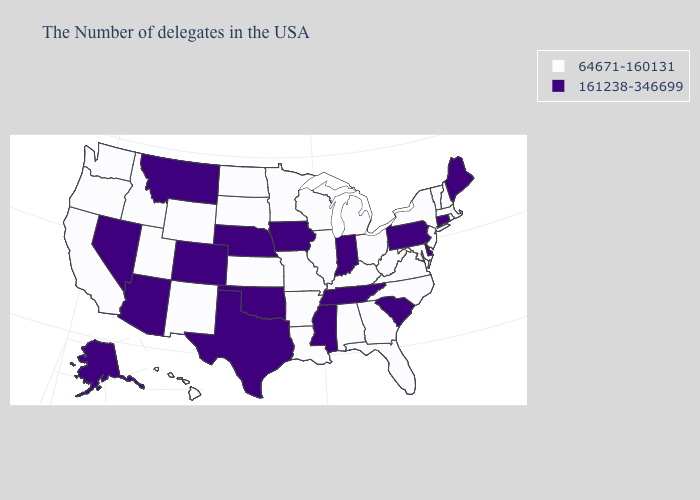What is the value of Alabama?
Concise answer only. 64671-160131. Name the states that have a value in the range 161238-346699?
Concise answer only. Maine, Connecticut, Delaware, Pennsylvania, South Carolina, Indiana, Tennessee, Mississippi, Iowa, Nebraska, Oklahoma, Texas, Colorado, Montana, Arizona, Nevada, Alaska. Does Mississippi have a higher value than Wisconsin?
Write a very short answer. Yes. Among the states that border Vermont , which have the lowest value?
Concise answer only. Massachusetts, New Hampshire, New York. Name the states that have a value in the range 161238-346699?
Keep it brief. Maine, Connecticut, Delaware, Pennsylvania, South Carolina, Indiana, Tennessee, Mississippi, Iowa, Nebraska, Oklahoma, Texas, Colorado, Montana, Arizona, Nevada, Alaska. What is the value of Massachusetts?
Concise answer only. 64671-160131. How many symbols are there in the legend?
Write a very short answer. 2. Name the states that have a value in the range 64671-160131?
Answer briefly. Massachusetts, Rhode Island, New Hampshire, Vermont, New York, New Jersey, Maryland, Virginia, North Carolina, West Virginia, Ohio, Florida, Georgia, Michigan, Kentucky, Alabama, Wisconsin, Illinois, Louisiana, Missouri, Arkansas, Minnesota, Kansas, South Dakota, North Dakota, Wyoming, New Mexico, Utah, Idaho, California, Washington, Oregon, Hawaii. Name the states that have a value in the range 161238-346699?
Short answer required. Maine, Connecticut, Delaware, Pennsylvania, South Carolina, Indiana, Tennessee, Mississippi, Iowa, Nebraska, Oklahoma, Texas, Colorado, Montana, Arizona, Nevada, Alaska. What is the value of Kentucky?
Give a very brief answer. 64671-160131. Name the states that have a value in the range 161238-346699?
Keep it brief. Maine, Connecticut, Delaware, Pennsylvania, South Carolina, Indiana, Tennessee, Mississippi, Iowa, Nebraska, Oklahoma, Texas, Colorado, Montana, Arizona, Nevada, Alaska. What is the value of Tennessee?
Short answer required. 161238-346699. Which states have the highest value in the USA?
Give a very brief answer. Maine, Connecticut, Delaware, Pennsylvania, South Carolina, Indiana, Tennessee, Mississippi, Iowa, Nebraska, Oklahoma, Texas, Colorado, Montana, Arizona, Nevada, Alaska. Which states have the lowest value in the South?
Short answer required. Maryland, Virginia, North Carolina, West Virginia, Florida, Georgia, Kentucky, Alabama, Louisiana, Arkansas. 